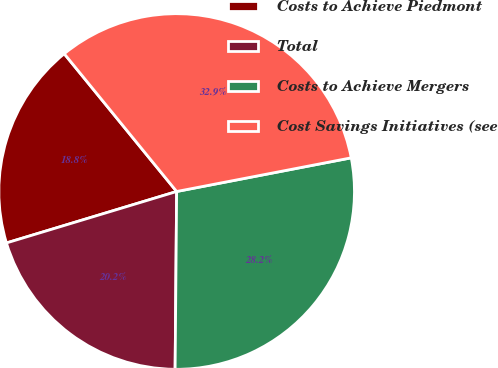Convert chart to OTSL. <chart><loc_0><loc_0><loc_500><loc_500><pie_chart><fcel>Costs to Achieve Piedmont<fcel>Total<fcel>Costs to Achieve Mergers<fcel>Cost Savings Initiatives (see<nl><fcel>18.78%<fcel>20.19%<fcel>28.17%<fcel>32.86%<nl></chart> 